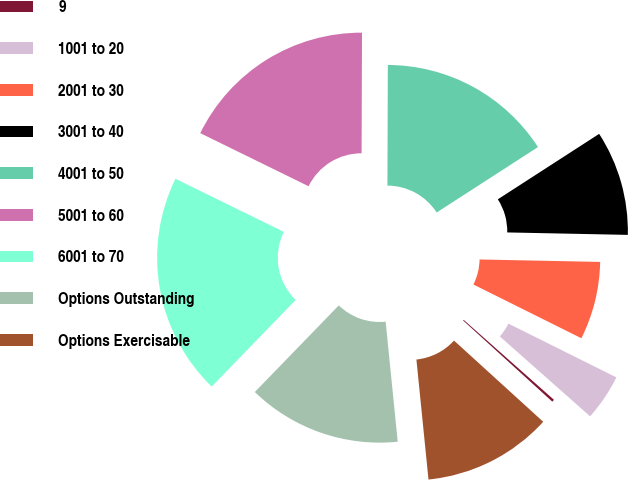Convert chart to OTSL. <chart><loc_0><loc_0><loc_500><loc_500><pie_chart><fcel>9<fcel>1001 to 20<fcel>2001 to 30<fcel>3001 to 40<fcel>4001 to 50<fcel>5001 to 60<fcel>6001 to 70<fcel>Options Outstanding<fcel>Options Exercisable<nl><fcel>0.22%<fcel>4.18%<fcel>7.03%<fcel>9.45%<fcel>15.82%<fcel>17.8%<fcel>20.0%<fcel>13.85%<fcel>11.65%<nl></chart> 